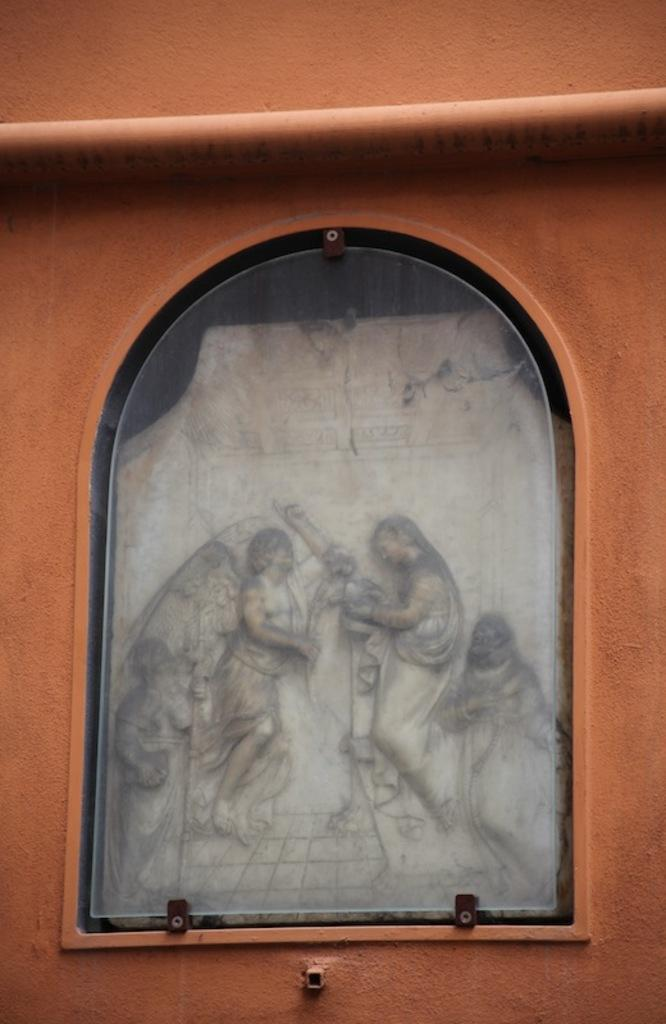What is the shape of the glass in the image? The glass in the image is in the shape of a window. What can be seen behind the glass? There are carvings of human beings behind the glass. What surrounds the glass in the image? There is a wall around the glass. What letter is being advertised on the glass in the image? There is no letter or advertisement present on the glass in the image; it features carvings of human beings. What type of bun is being served on the wall in the image? There is no bun present in the image; it features a wall around the glass with carvings of human beings behind it. 